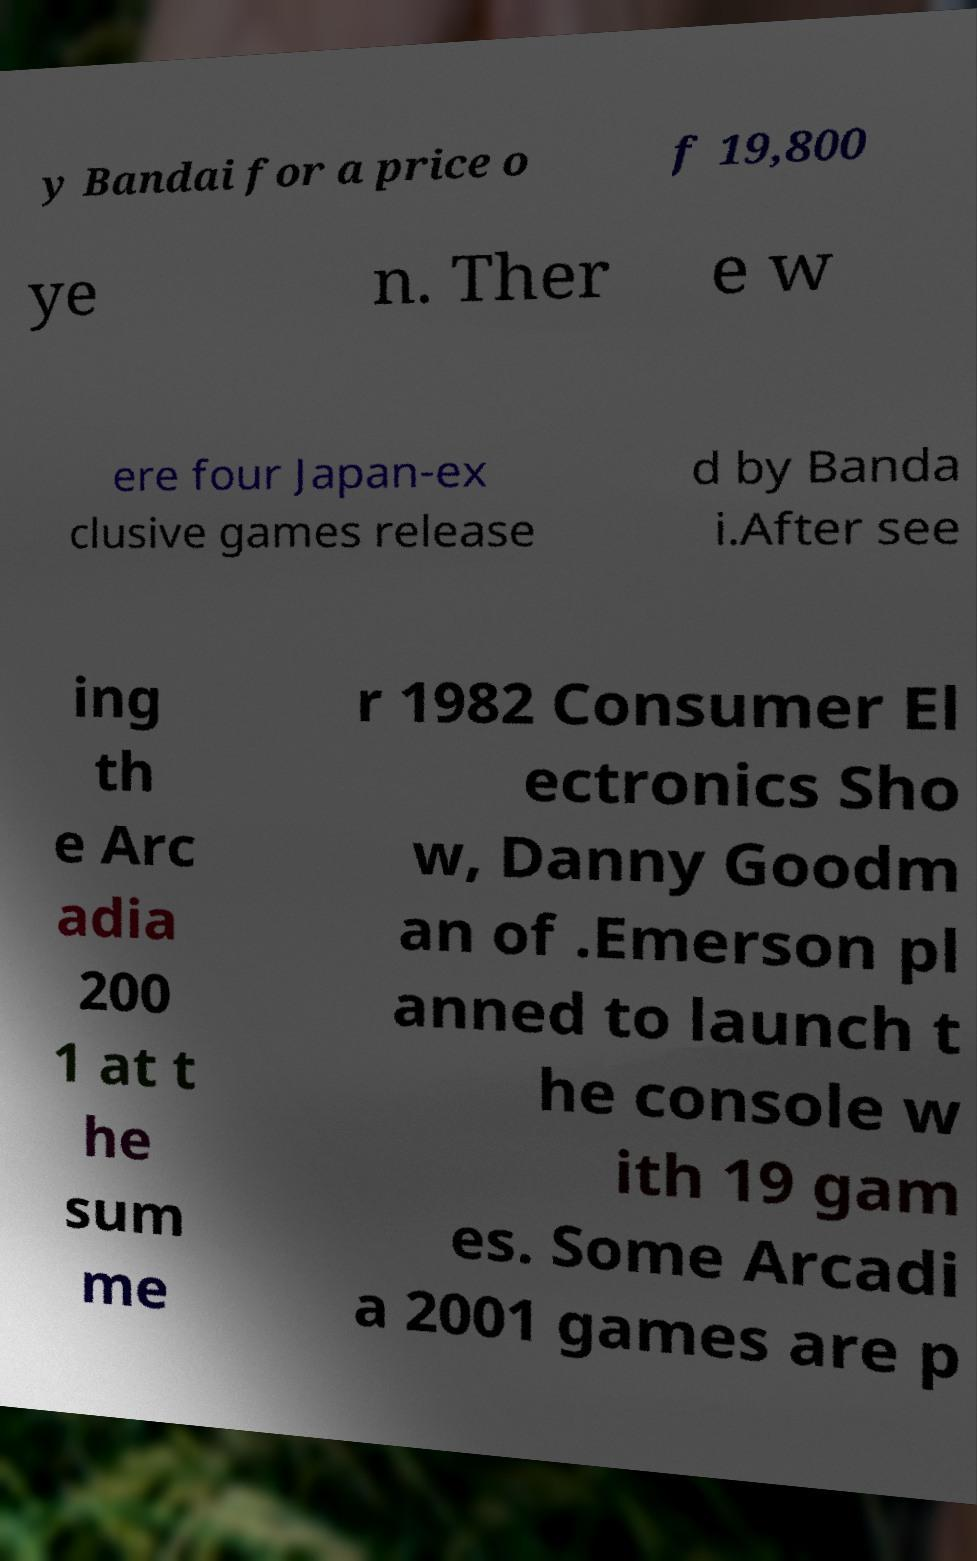Please identify and transcribe the text found in this image. y Bandai for a price o f 19,800 ye n. Ther e w ere four Japan-ex clusive games release d by Banda i.After see ing th e Arc adia 200 1 at t he sum me r 1982 Consumer El ectronics Sho w, Danny Goodm an of .Emerson pl anned to launch t he console w ith 19 gam es. Some Arcadi a 2001 games are p 